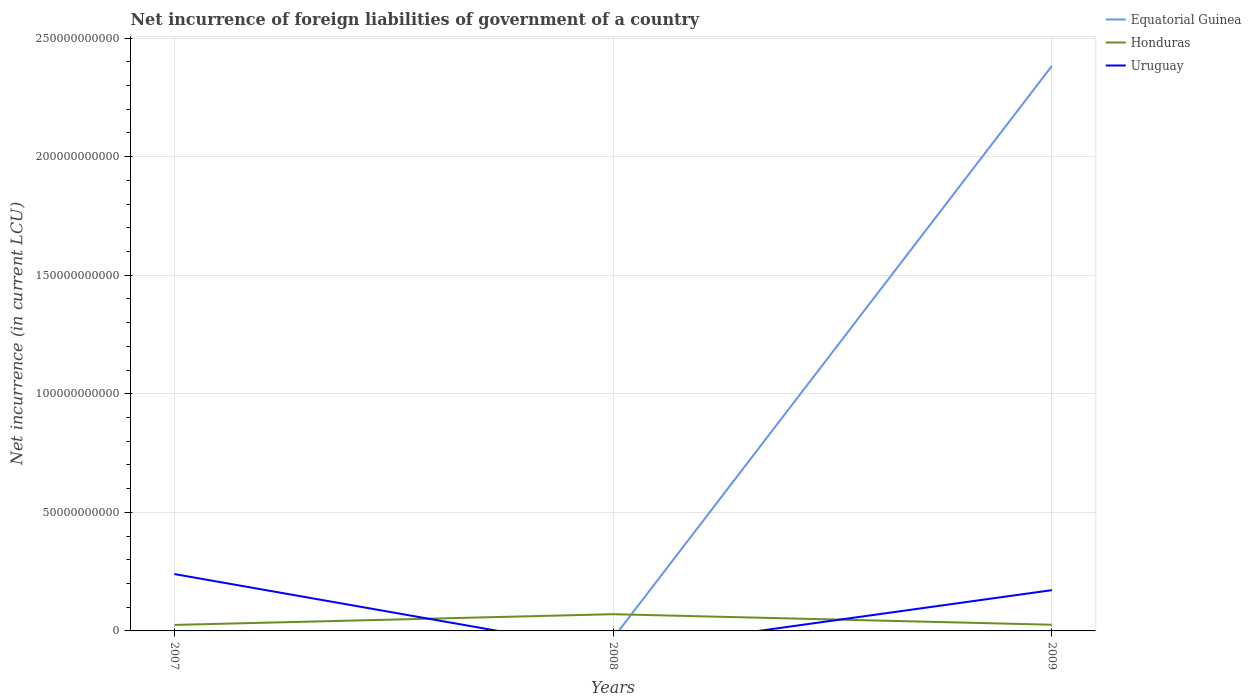Across all years, what is the maximum net incurrence of foreign liabilities in Uruguay?
Your response must be concise. 0. What is the total net incurrence of foreign liabilities in Uruguay in the graph?
Offer a very short reply. 6.78e+09. What is the difference between the highest and the second highest net incurrence of foreign liabilities in Equatorial Guinea?
Make the answer very short. 2.38e+11. What is the difference between the highest and the lowest net incurrence of foreign liabilities in Uruguay?
Offer a very short reply. 2. How many lines are there?
Provide a succinct answer. 3. What is the difference between two consecutive major ticks on the Y-axis?
Keep it short and to the point. 5.00e+1. Are the values on the major ticks of Y-axis written in scientific E-notation?
Your answer should be very brief. No. Where does the legend appear in the graph?
Offer a very short reply. Top right. How many legend labels are there?
Provide a short and direct response. 3. How are the legend labels stacked?
Keep it short and to the point. Vertical. What is the title of the graph?
Keep it short and to the point. Net incurrence of foreign liabilities of government of a country. Does "Mali" appear as one of the legend labels in the graph?
Give a very brief answer. No. What is the label or title of the X-axis?
Keep it short and to the point. Years. What is the label or title of the Y-axis?
Offer a terse response. Net incurrence (in current LCU). What is the Net incurrence (in current LCU) of Honduras in 2007?
Your answer should be very brief. 2.53e+09. What is the Net incurrence (in current LCU) in Uruguay in 2007?
Make the answer very short. 2.40e+1. What is the Net incurrence (in current LCU) in Equatorial Guinea in 2008?
Offer a terse response. 0. What is the Net incurrence (in current LCU) of Honduras in 2008?
Your answer should be compact. 7.05e+09. What is the Net incurrence (in current LCU) in Uruguay in 2008?
Provide a succinct answer. 0. What is the Net incurrence (in current LCU) of Equatorial Guinea in 2009?
Provide a succinct answer. 2.38e+11. What is the Net incurrence (in current LCU) in Honduras in 2009?
Provide a succinct answer. 2.61e+09. What is the Net incurrence (in current LCU) in Uruguay in 2009?
Your answer should be very brief. 1.72e+1. Across all years, what is the maximum Net incurrence (in current LCU) in Equatorial Guinea?
Your answer should be very brief. 2.38e+11. Across all years, what is the maximum Net incurrence (in current LCU) in Honduras?
Your response must be concise. 7.05e+09. Across all years, what is the maximum Net incurrence (in current LCU) of Uruguay?
Your response must be concise. 2.40e+1. Across all years, what is the minimum Net incurrence (in current LCU) of Equatorial Guinea?
Ensure brevity in your answer.  0. Across all years, what is the minimum Net incurrence (in current LCU) of Honduras?
Your response must be concise. 2.53e+09. What is the total Net incurrence (in current LCU) of Equatorial Guinea in the graph?
Your answer should be compact. 2.38e+11. What is the total Net incurrence (in current LCU) in Honduras in the graph?
Provide a short and direct response. 1.22e+1. What is the total Net incurrence (in current LCU) in Uruguay in the graph?
Give a very brief answer. 4.12e+1. What is the difference between the Net incurrence (in current LCU) in Honduras in 2007 and that in 2008?
Provide a succinct answer. -4.52e+09. What is the difference between the Net incurrence (in current LCU) of Honduras in 2007 and that in 2009?
Your answer should be compact. -8.36e+07. What is the difference between the Net incurrence (in current LCU) of Uruguay in 2007 and that in 2009?
Ensure brevity in your answer.  6.78e+09. What is the difference between the Net incurrence (in current LCU) of Honduras in 2008 and that in 2009?
Keep it short and to the point. 4.44e+09. What is the difference between the Net incurrence (in current LCU) of Honduras in 2007 and the Net incurrence (in current LCU) of Uruguay in 2009?
Offer a very short reply. -1.47e+1. What is the difference between the Net incurrence (in current LCU) of Honduras in 2008 and the Net incurrence (in current LCU) of Uruguay in 2009?
Offer a very short reply. -1.01e+1. What is the average Net incurrence (in current LCU) of Equatorial Guinea per year?
Keep it short and to the point. 7.94e+1. What is the average Net incurrence (in current LCU) of Honduras per year?
Provide a succinct answer. 4.07e+09. What is the average Net incurrence (in current LCU) in Uruguay per year?
Make the answer very short. 1.37e+1. In the year 2007, what is the difference between the Net incurrence (in current LCU) in Honduras and Net incurrence (in current LCU) in Uruguay?
Your response must be concise. -2.14e+1. In the year 2009, what is the difference between the Net incurrence (in current LCU) in Equatorial Guinea and Net incurrence (in current LCU) in Honduras?
Make the answer very short. 2.36e+11. In the year 2009, what is the difference between the Net incurrence (in current LCU) of Equatorial Guinea and Net incurrence (in current LCU) of Uruguay?
Keep it short and to the point. 2.21e+11. In the year 2009, what is the difference between the Net incurrence (in current LCU) in Honduras and Net incurrence (in current LCU) in Uruguay?
Your answer should be very brief. -1.46e+1. What is the ratio of the Net incurrence (in current LCU) in Honduras in 2007 to that in 2008?
Give a very brief answer. 0.36. What is the ratio of the Net incurrence (in current LCU) of Uruguay in 2007 to that in 2009?
Make the answer very short. 1.39. What is the ratio of the Net incurrence (in current LCU) in Honduras in 2008 to that in 2009?
Make the answer very short. 2.7. What is the difference between the highest and the second highest Net incurrence (in current LCU) in Honduras?
Your answer should be very brief. 4.44e+09. What is the difference between the highest and the lowest Net incurrence (in current LCU) of Equatorial Guinea?
Your response must be concise. 2.38e+11. What is the difference between the highest and the lowest Net incurrence (in current LCU) of Honduras?
Offer a terse response. 4.52e+09. What is the difference between the highest and the lowest Net incurrence (in current LCU) of Uruguay?
Provide a short and direct response. 2.40e+1. 